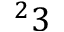<formula> <loc_0><loc_0><loc_500><loc_500>^ { 2 } 3</formula> 